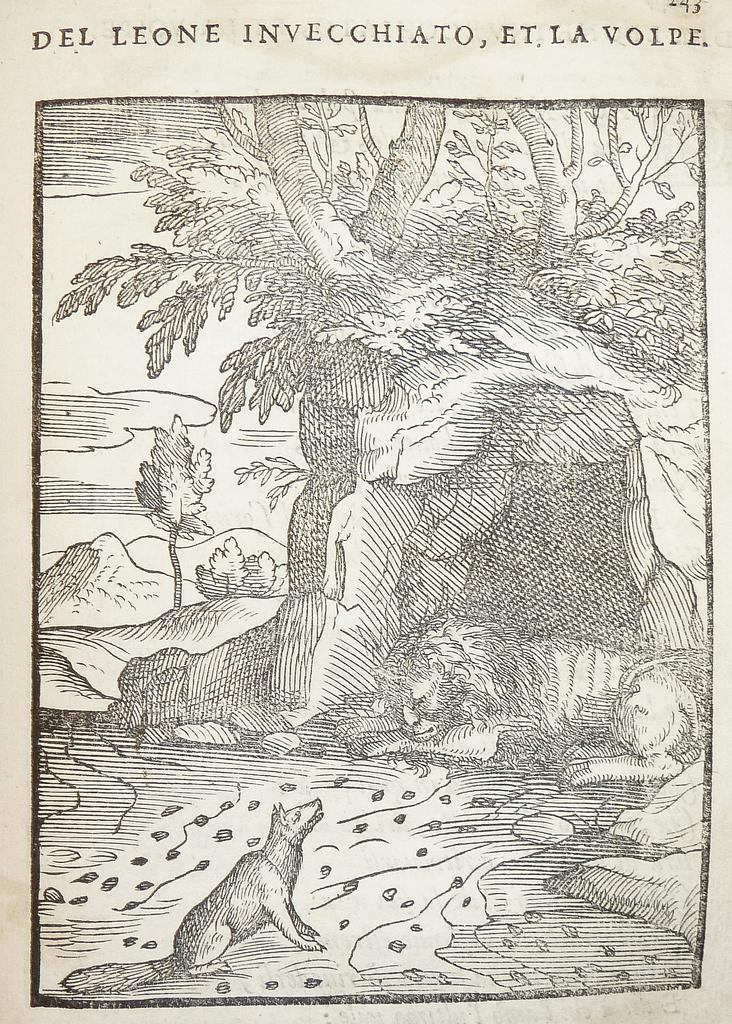What is the style of the image? The image appears to be a sketch. What animal is at the bottom of the image? There is a fox at the bottom of the image. What animal is on the right side of the image? There is a lion on the right side of the image. What can be seen in the background of the image? There are trees in the background of the image. What is written or drawn at the top of the image? There is text at the top of the image. Where is the playground located in the image? There is no playground present in the image. What type of mask is the lion wearing in the image? There is no mask present in the image; the lion is not wearing any mask. 